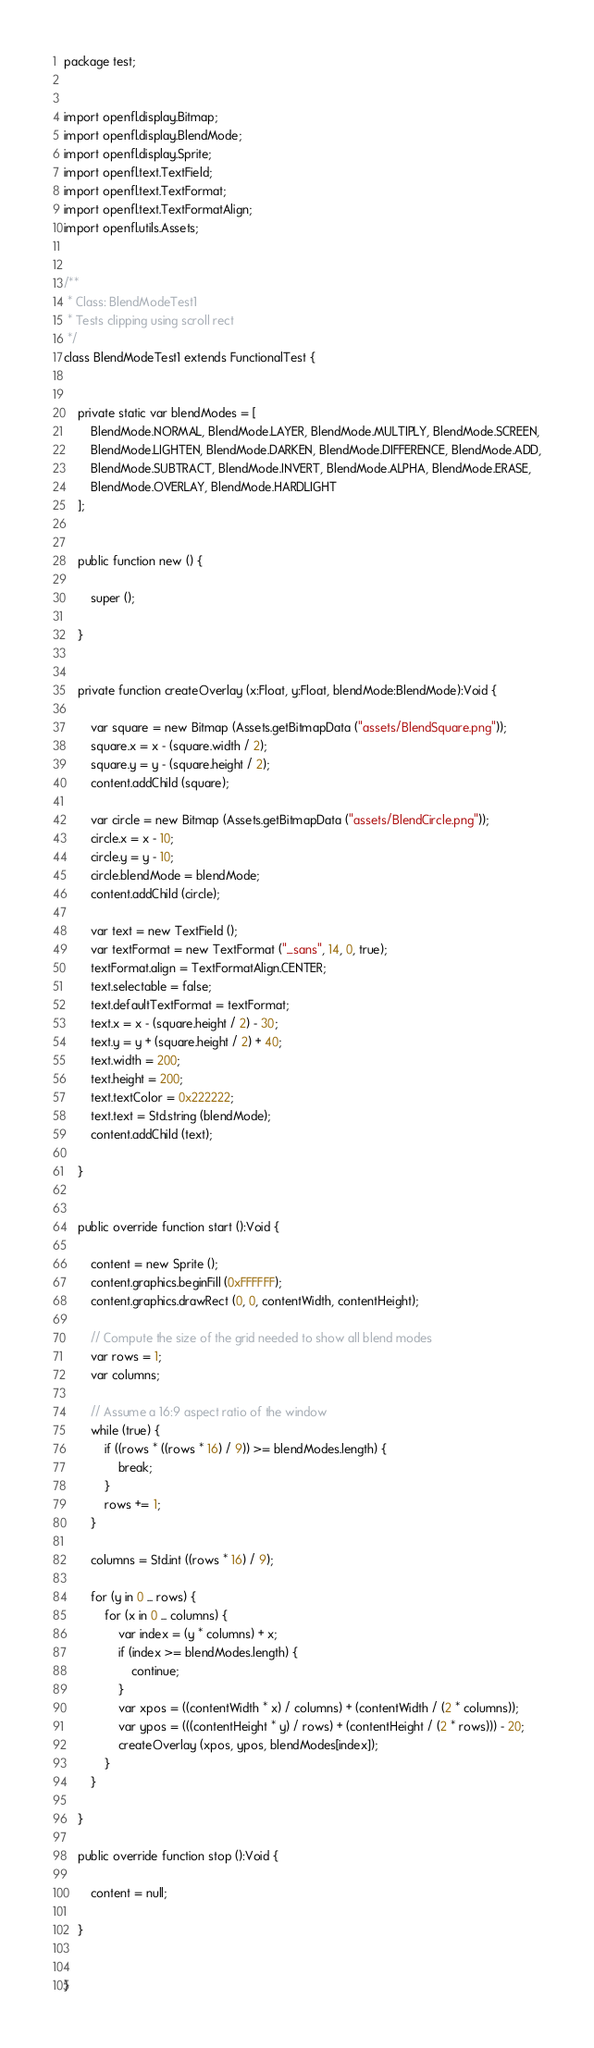Convert code to text. <code><loc_0><loc_0><loc_500><loc_500><_Haxe_>package test;


import openfl.display.Bitmap;
import openfl.display.BlendMode;
import openfl.display.Sprite;
import openfl.text.TextField;
import openfl.text.TextFormat;
import openfl.text.TextFormatAlign;
import openfl.utils.Assets;


/**
 * Class: BlendModeTest1
 * Tests clipping using scroll rect
 */
class BlendModeTest1 extends FunctionalTest {
	
	
	private static var blendModes = [
		BlendMode.NORMAL, BlendMode.LAYER, BlendMode.MULTIPLY, BlendMode.SCREEN,
		BlendMode.LIGHTEN, BlendMode.DARKEN, BlendMode.DIFFERENCE, BlendMode.ADD,
		BlendMode.SUBTRACT, BlendMode.INVERT, BlendMode.ALPHA, BlendMode.ERASE,
		BlendMode.OVERLAY, BlendMode.HARDLIGHT
	];
	
	
	public function new () {
		
		super ();
		
	}
	
	
	private function createOverlay (x:Float, y:Float, blendMode:BlendMode):Void {
		
		var square = new Bitmap (Assets.getBitmapData ("assets/BlendSquare.png"));
		square.x = x - (square.width / 2);
		square.y = y - (square.height / 2);
		content.addChild (square);
		
		var circle = new Bitmap (Assets.getBitmapData ("assets/BlendCircle.png"));
		circle.x = x - 10;
		circle.y = y - 10;
		circle.blendMode = blendMode;
		content.addChild (circle);

		var text = new TextField ();
		var textFormat = new TextFormat ("_sans", 14, 0, true);
		textFormat.align = TextFormatAlign.CENTER;
		text.selectable = false;
		text.defaultTextFormat = textFormat;
		text.x = x - (square.height / 2) - 30;
		text.y = y + (square.height / 2) + 40;
		text.width = 200;
		text.height = 200;
		text.textColor = 0x222222;
		text.text = Std.string (blendMode);
		content.addChild (text);
		
	}
	
	
	public override function start ():Void {
		
		content = new Sprite ();
		content.graphics.beginFill (0xFFFFFF);
		content.graphics.drawRect (0, 0, contentWidth, contentHeight);
		
		// Compute the size of the grid needed to show all blend modes
		var rows = 1;
		var columns;
		
		// Assume a 16:9 aspect ratio of the window
		while (true) {
			if ((rows * ((rows * 16) / 9)) >= blendModes.length) {
				break;
			}
			rows += 1;
		}
		
		columns = Std.int ((rows * 16) / 9);
		
		for (y in 0 ... rows) {
			for (x in 0 ... columns) {
				var index = (y * columns) + x;
				if (index >= blendModes.length) {
					continue;
				}
				var xpos = ((contentWidth * x) / columns) + (contentWidth / (2 * columns));
				var ypos = (((contentHeight * y) / rows) + (contentHeight / (2 * rows))) - 20;
				createOverlay (xpos, ypos, blendModes[index]);
			}
		}
		
	}

	public override function stop ():Void {
		
		content = null;
		
	}
	
	
}</code> 